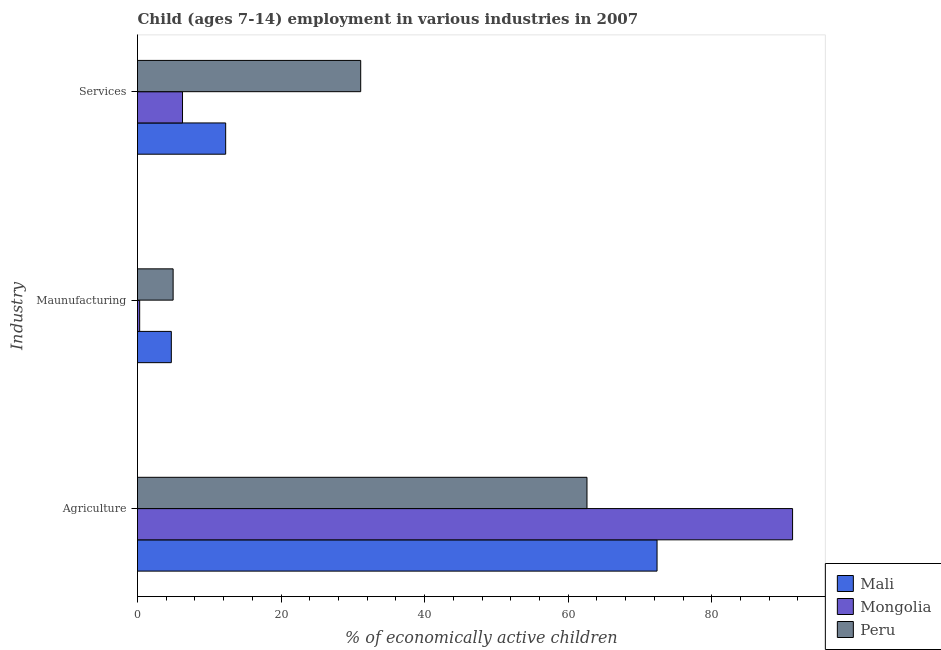Are the number of bars on each tick of the Y-axis equal?
Offer a very short reply. Yes. How many bars are there on the 2nd tick from the top?
Provide a succinct answer. 3. How many bars are there on the 1st tick from the bottom?
Provide a succinct answer. 3. What is the label of the 3rd group of bars from the top?
Provide a short and direct response. Agriculture. What is the percentage of economically active children in manufacturing in Peru?
Offer a very short reply. 4.96. Across all countries, what is the maximum percentage of economically active children in manufacturing?
Keep it short and to the point. 4.96. Across all countries, what is the minimum percentage of economically active children in agriculture?
Give a very brief answer. 62.61. In which country was the percentage of economically active children in manufacturing minimum?
Your answer should be very brief. Mongolia. What is the total percentage of economically active children in agriculture in the graph?
Offer a terse response. 226.23. What is the difference between the percentage of economically active children in services in Peru and that in Mongolia?
Your response must be concise. 24.82. What is the difference between the percentage of economically active children in services in Mongolia and the percentage of economically active children in agriculture in Peru?
Your answer should be compact. -56.34. What is the average percentage of economically active children in manufacturing per country?
Your answer should be very brief. 3.32. What is the difference between the percentage of economically active children in agriculture and percentage of economically active children in manufacturing in Mongolia?
Your answer should be very brief. 90.95. What is the ratio of the percentage of economically active children in services in Mali to that in Mongolia?
Offer a terse response. 1.96. What is the difference between the highest and the second highest percentage of economically active children in services?
Provide a short and direct response. 18.81. What is the difference between the highest and the lowest percentage of economically active children in manufacturing?
Offer a very short reply. 4.66. What does the 2nd bar from the top in Maunufacturing represents?
Make the answer very short. Mongolia. What does the 1st bar from the bottom in Maunufacturing represents?
Your answer should be compact. Mali. Is it the case that in every country, the sum of the percentage of economically active children in agriculture and percentage of economically active children in manufacturing is greater than the percentage of economically active children in services?
Your response must be concise. Yes. How many bars are there?
Your response must be concise. 9. How many countries are there in the graph?
Your response must be concise. 3. Does the graph contain any zero values?
Offer a very short reply. No. How many legend labels are there?
Make the answer very short. 3. How are the legend labels stacked?
Your response must be concise. Vertical. What is the title of the graph?
Provide a short and direct response. Child (ages 7-14) employment in various industries in 2007. Does "Myanmar" appear as one of the legend labels in the graph?
Your response must be concise. No. What is the label or title of the X-axis?
Keep it short and to the point. % of economically active children. What is the label or title of the Y-axis?
Ensure brevity in your answer.  Industry. What is the % of economically active children in Mali in Agriculture?
Your answer should be very brief. 72.37. What is the % of economically active children in Mongolia in Agriculture?
Offer a terse response. 91.25. What is the % of economically active children in Peru in Agriculture?
Offer a very short reply. 62.61. What is the % of economically active children of Mali in Maunufacturing?
Ensure brevity in your answer.  4.71. What is the % of economically active children of Peru in Maunufacturing?
Offer a terse response. 4.96. What is the % of economically active children of Mali in Services?
Ensure brevity in your answer.  12.28. What is the % of economically active children in Mongolia in Services?
Your answer should be very brief. 6.27. What is the % of economically active children in Peru in Services?
Provide a succinct answer. 31.09. Across all Industry, what is the maximum % of economically active children of Mali?
Give a very brief answer. 72.37. Across all Industry, what is the maximum % of economically active children of Mongolia?
Ensure brevity in your answer.  91.25. Across all Industry, what is the maximum % of economically active children of Peru?
Your response must be concise. 62.61. Across all Industry, what is the minimum % of economically active children of Mali?
Provide a succinct answer. 4.71. Across all Industry, what is the minimum % of economically active children in Mongolia?
Give a very brief answer. 0.3. Across all Industry, what is the minimum % of economically active children in Peru?
Offer a very short reply. 4.96. What is the total % of economically active children in Mali in the graph?
Make the answer very short. 89.36. What is the total % of economically active children of Mongolia in the graph?
Offer a very short reply. 97.82. What is the total % of economically active children of Peru in the graph?
Your response must be concise. 98.66. What is the difference between the % of economically active children of Mali in Agriculture and that in Maunufacturing?
Your response must be concise. 67.66. What is the difference between the % of economically active children of Mongolia in Agriculture and that in Maunufacturing?
Give a very brief answer. 90.95. What is the difference between the % of economically active children of Peru in Agriculture and that in Maunufacturing?
Keep it short and to the point. 57.65. What is the difference between the % of economically active children in Mali in Agriculture and that in Services?
Give a very brief answer. 60.09. What is the difference between the % of economically active children of Mongolia in Agriculture and that in Services?
Offer a terse response. 84.98. What is the difference between the % of economically active children in Peru in Agriculture and that in Services?
Offer a terse response. 31.52. What is the difference between the % of economically active children of Mali in Maunufacturing and that in Services?
Your answer should be very brief. -7.57. What is the difference between the % of economically active children in Mongolia in Maunufacturing and that in Services?
Give a very brief answer. -5.97. What is the difference between the % of economically active children of Peru in Maunufacturing and that in Services?
Offer a terse response. -26.13. What is the difference between the % of economically active children in Mali in Agriculture and the % of economically active children in Mongolia in Maunufacturing?
Provide a short and direct response. 72.07. What is the difference between the % of economically active children in Mali in Agriculture and the % of economically active children in Peru in Maunufacturing?
Your response must be concise. 67.41. What is the difference between the % of economically active children of Mongolia in Agriculture and the % of economically active children of Peru in Maunufacturing?
Make the answer very short. 86.29. What is the difference between the % of economically active children of Mali in Agriculture and the % of economically active children of Mongolia in Services?
Your answer should be very brief. 66.1. What is the difference between the % of economically active children in Mali in Agriculture and the % of economically active children in Peru in Services?
Your response must be concise. 41.28. What is the difference between the % of economically active children of Mongolia in Agriculture and the % of economically active children of Peru in Services?
Provide a short and direct response. 60.16. What is the difference between the % of economically active children in Mali in Maunufacturing and the % of economically active children in Mongolia in Services?
Keep it short and to the point. -1.56. What is the difference between the % of economically active children in Mali in Maunufacturing and the % of economically active children in Peru in Services?
Give a very brief answer. -26.38. What is the difference between the % of economically active children of Mongolia in Maunufacturing and the % of economically active children of Peru in Services?
Your response must be concise. -30.79. What is the average % of economically active children in Mali per Industry?
Your answer should be very brief. 29.79. What is the average % of economically active children in Mongolia per Industry?
Make the answer very short. 32.61. What is the average % of economically active children of Peru per Industry?
Give a very brief answer. 32.89. What is the difference between the % of economically active children of Mali and % of economically active children of Mongolia in Agriculture?
Offer a terse response. -18.88. What is the difference between the % of economically active children in Mali and % of economically active children in Peru in Agriculture?
Make the answer very short. 9.76. What is the difference between the % of economically active children in Mongolia and % of economically active children in Peru in Agriculture?
Offer a terse response. 28.64. What is the difference between the % of economically active children of Mali and % of economically active children of Mongolia in Maunufacturing?
Your answer should be compact. 4.41. What is the difference between the % of economically active children in Mongolia and % of economically active children in Peru in Maunufacturing?
Your answer should be compact. -4.66. What is the difference between the % of economically active children in Mali and % of economically active children in Mongolia in Services?
Your answer should be compact. 6.01. What is the difference between the % of economically active children in Mali and % of economically active children in Peru in Services?
Offer a terse response. -18.81. What is the difference between the % of economically active children of Mongolia and % of economically active children of Peru in Services?
Offer a terse response. -24.82. What is the ratio of the % of economically active children in Mali in Agriculture to that in Maunufacturing?
Give a very brief answer. 15.37. What is the ratio of the % of economically active children in Mongolia in Agriculture to that in Maunufacturing?
Make the answer very short. 304.17. What is the ratio of the % of economically active children of Peru in Agriculture to that in Maunufacturing?
Your response must be concise. 12.62. What is the ratio of the % of economically active children of Mali in Agriculture to that in Services?
Offer a very short reply. 5.89. What is the ratio of the % of economically active children in Mongolia in Agriculture to that in Services?
Your response must be concise. 14.55. What is the ratio of the % of economically active children in Peru in Agriculture to that in Services?
Your answer should be very brief. 2.01. What is the ratio of the % of economically active children of Mali in Maunufacturing to that in Services?
Make the answer very short. 0.38. What is the ratio of the % of economically active children of Mongolia in Maunufacturing to that in Services?
Your response must be concise. 0.05. What is the ratio of the % of economically active children of Peru in Maunufacturing to that in Services?
Offer a terse response. 0.16. What is the difference between the highest and the second highest % of economically active children of Mali?
Your response must be concise. 60.09. What is the difference between the highest and the second highest % of economically active children of Mongolia?
Offer a terse response. 84.98. What is the difference between the highest and the second highest % of economically active children in Peru?
Ensure brevity in your answer.  31.52. What is the difference between the highest and the lowest % of economically active children in Mali?
Provide a short and direct response. 67.66. What is the difference between the highest and the lowest % of economically active children of Mongolia?
Your answer should be very brief. 90.95. What is the difference between the highest and the lowest % of economically active children in Peru?
Make the answer very short. 57.65. 